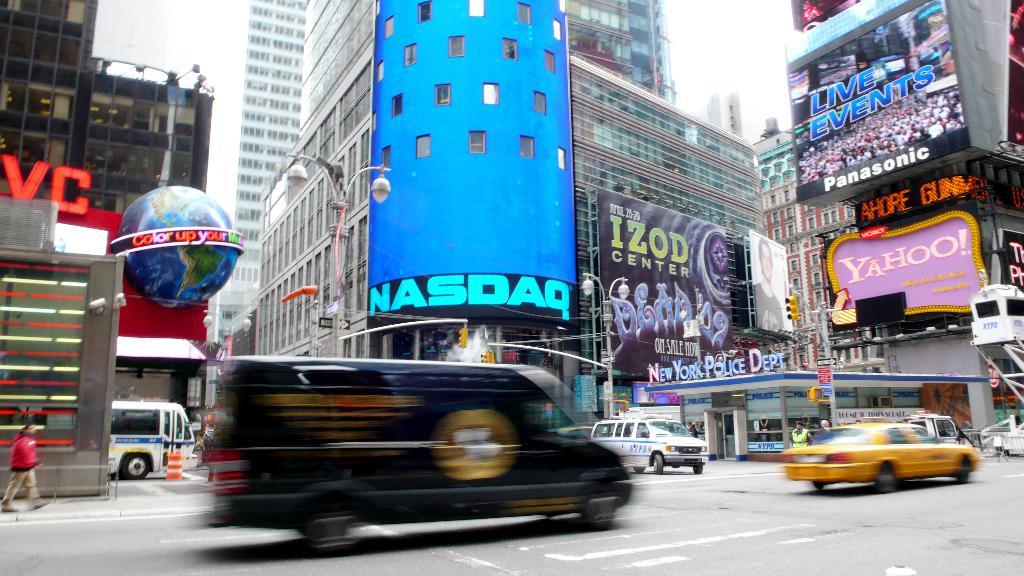Provide a one-sentence caption for the provided image. a NASDAQ sign that is on a building. 